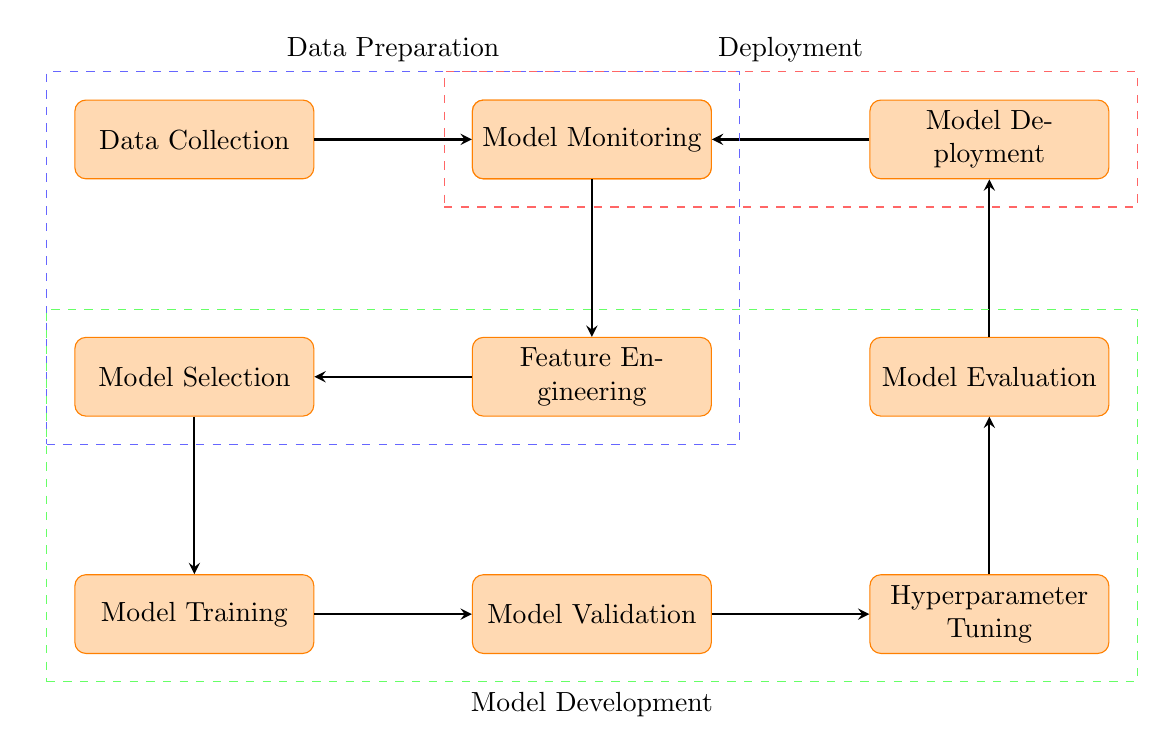What is the first step in the diagram? The diagram clearly starts with the node labeled "Data Collection," which indicates it's the first step in the workflow.
Answer: Data Collection How many main sections are there in the diagram? There are three dashed sections labeled: Data Preparation, Model Development, and Deployment, indicating they divide the process into main categories.
Answer: Three Which process follows Data Preprocessing? Directly after "Data Preprocessing," the next node is "Feature Engineering," showing the sequence in the workflow.
Answer: Feature Engineering What process comes before Model Validation? Prior to the "Model Validation" process, the "Model Training" step occurs, indicating the order of operations leading into validation.
Answer: Model Training What is the last step in the workflow? The final node in the diagram is labeled "Model Monitoring," which shows it is the concluding step in the workflow process.
Answer: Model Monitoring Which two processes are grouped under Model Development? The two processes inside the "Model Development" section are "Model Selection" and "Training," as indicated by their positioning within the dashed green area.
Answer: Model Selection and Training How many arrows are present in the diagram? Counting the arrows connecting the processes reveals a total of eight arrows, indicating the sequence and relationships between the steps.
Answer: Eight What is the focus of the dashed red section? The dashed red section named "Deployment" encapsulates the final two processes: "Model Deployment" and "Model Monitoring," showing the focus on the deployment phase.
Answer: Deployment Which step occurs directly after Hyperparameter Tuning? Following "Hyperparameter Tuning," the next step in the workflow is "Model Evaluation," as shown by the arrow connecting them.
Answer: Model Evaluation 